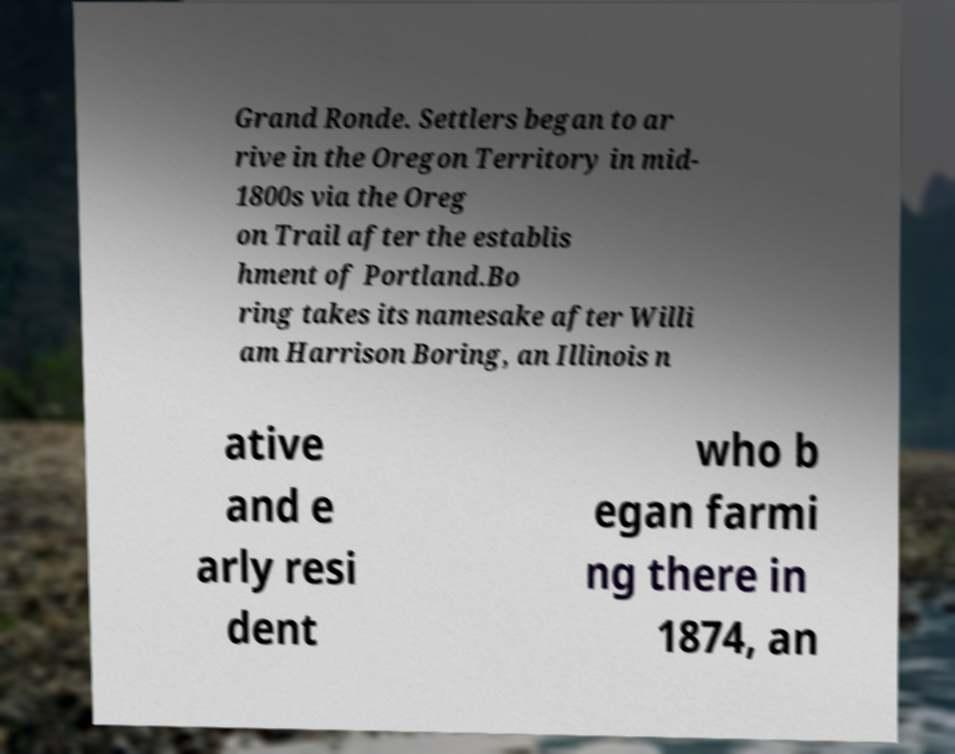Could you extract and type out the text from this image? Grand Ronde. Settlers began to ar rive in the Oregon Territory in mid- 1800s via the Oreg on Trail after the establis hment of Portland.Bo ring takes its namesake after Willi am Harrison Boring, an Illinois n ative and e arly resi dent who b egan farmi ng there in 1874, an 